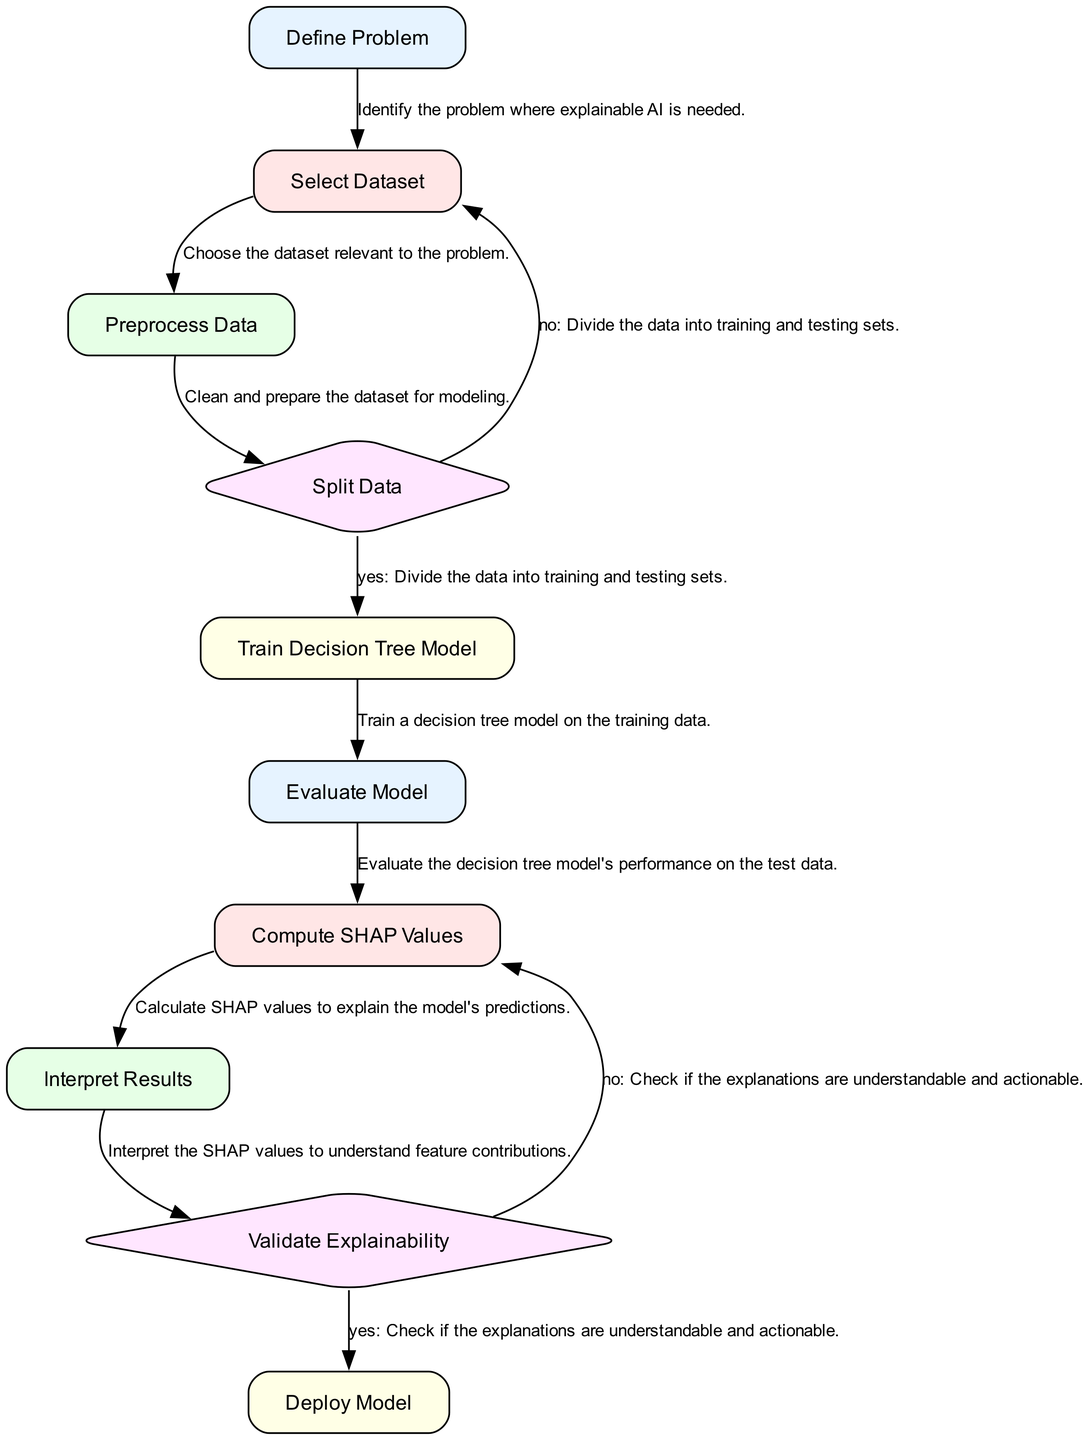What is the first step in the process? The diagram starts with the "Define Problem" node, which indicates the first step in the process of developing an explainable AI model.
Answer: Define Problem How many decision nodes are present in the diagram? There are two decision nodes in the diagram: "Split Data" and "Validate Explainability".
Answer: 2 What step follows computing SHAP values? After computing SHAP values, the next step is to interpret the results.
Answer: Interpret Results If the data splitting decision is "no", which step will be revisited? If the data splitting decision is "no," the process returns to the "Select Dataset" step.
Answer: Select Dataset What action is taken after validating explainability? Once the explainability is validated, the model will be deployed as the next step.
Answer: Deploy Model What feature does the "Train Decision Tree Model" node represent? This node represents the process of training a decision tree model using the training data.
Answer: Train Decision Tree Model Which node comes after evaluating the model? After evaluating the model, the next step is to compute SHAP values.
Answer: Compute SHAP Values What happens if the explanations are not understandable? If the explanations are not understandable, the process returns to the "Compute SHAP Values" step.
Answer: Compute SHAP Values How many processes are shown in the diagram? There are eight process nodes in the diagram.
Answer: 8 